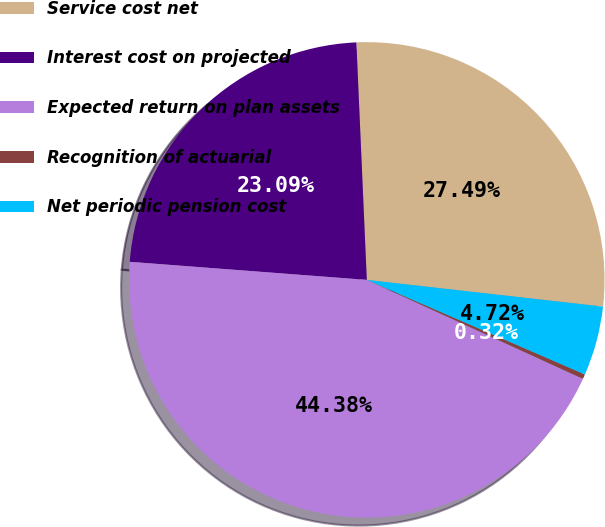Convert chart. <chart><loc_0><loc_0><loc_500><loc_500><pie_chart><fcel>Service cost net<fcel>Interest cost on projected<fcel>Expected return on plan assets<fcel>Recognition of actuarial<fcel>Net periodic pension cost<nl><fcel>27.49%<fcel>23.09%<fcel>44.38%<fcel>0.32%<fcel>4.72%<nl></chart> 